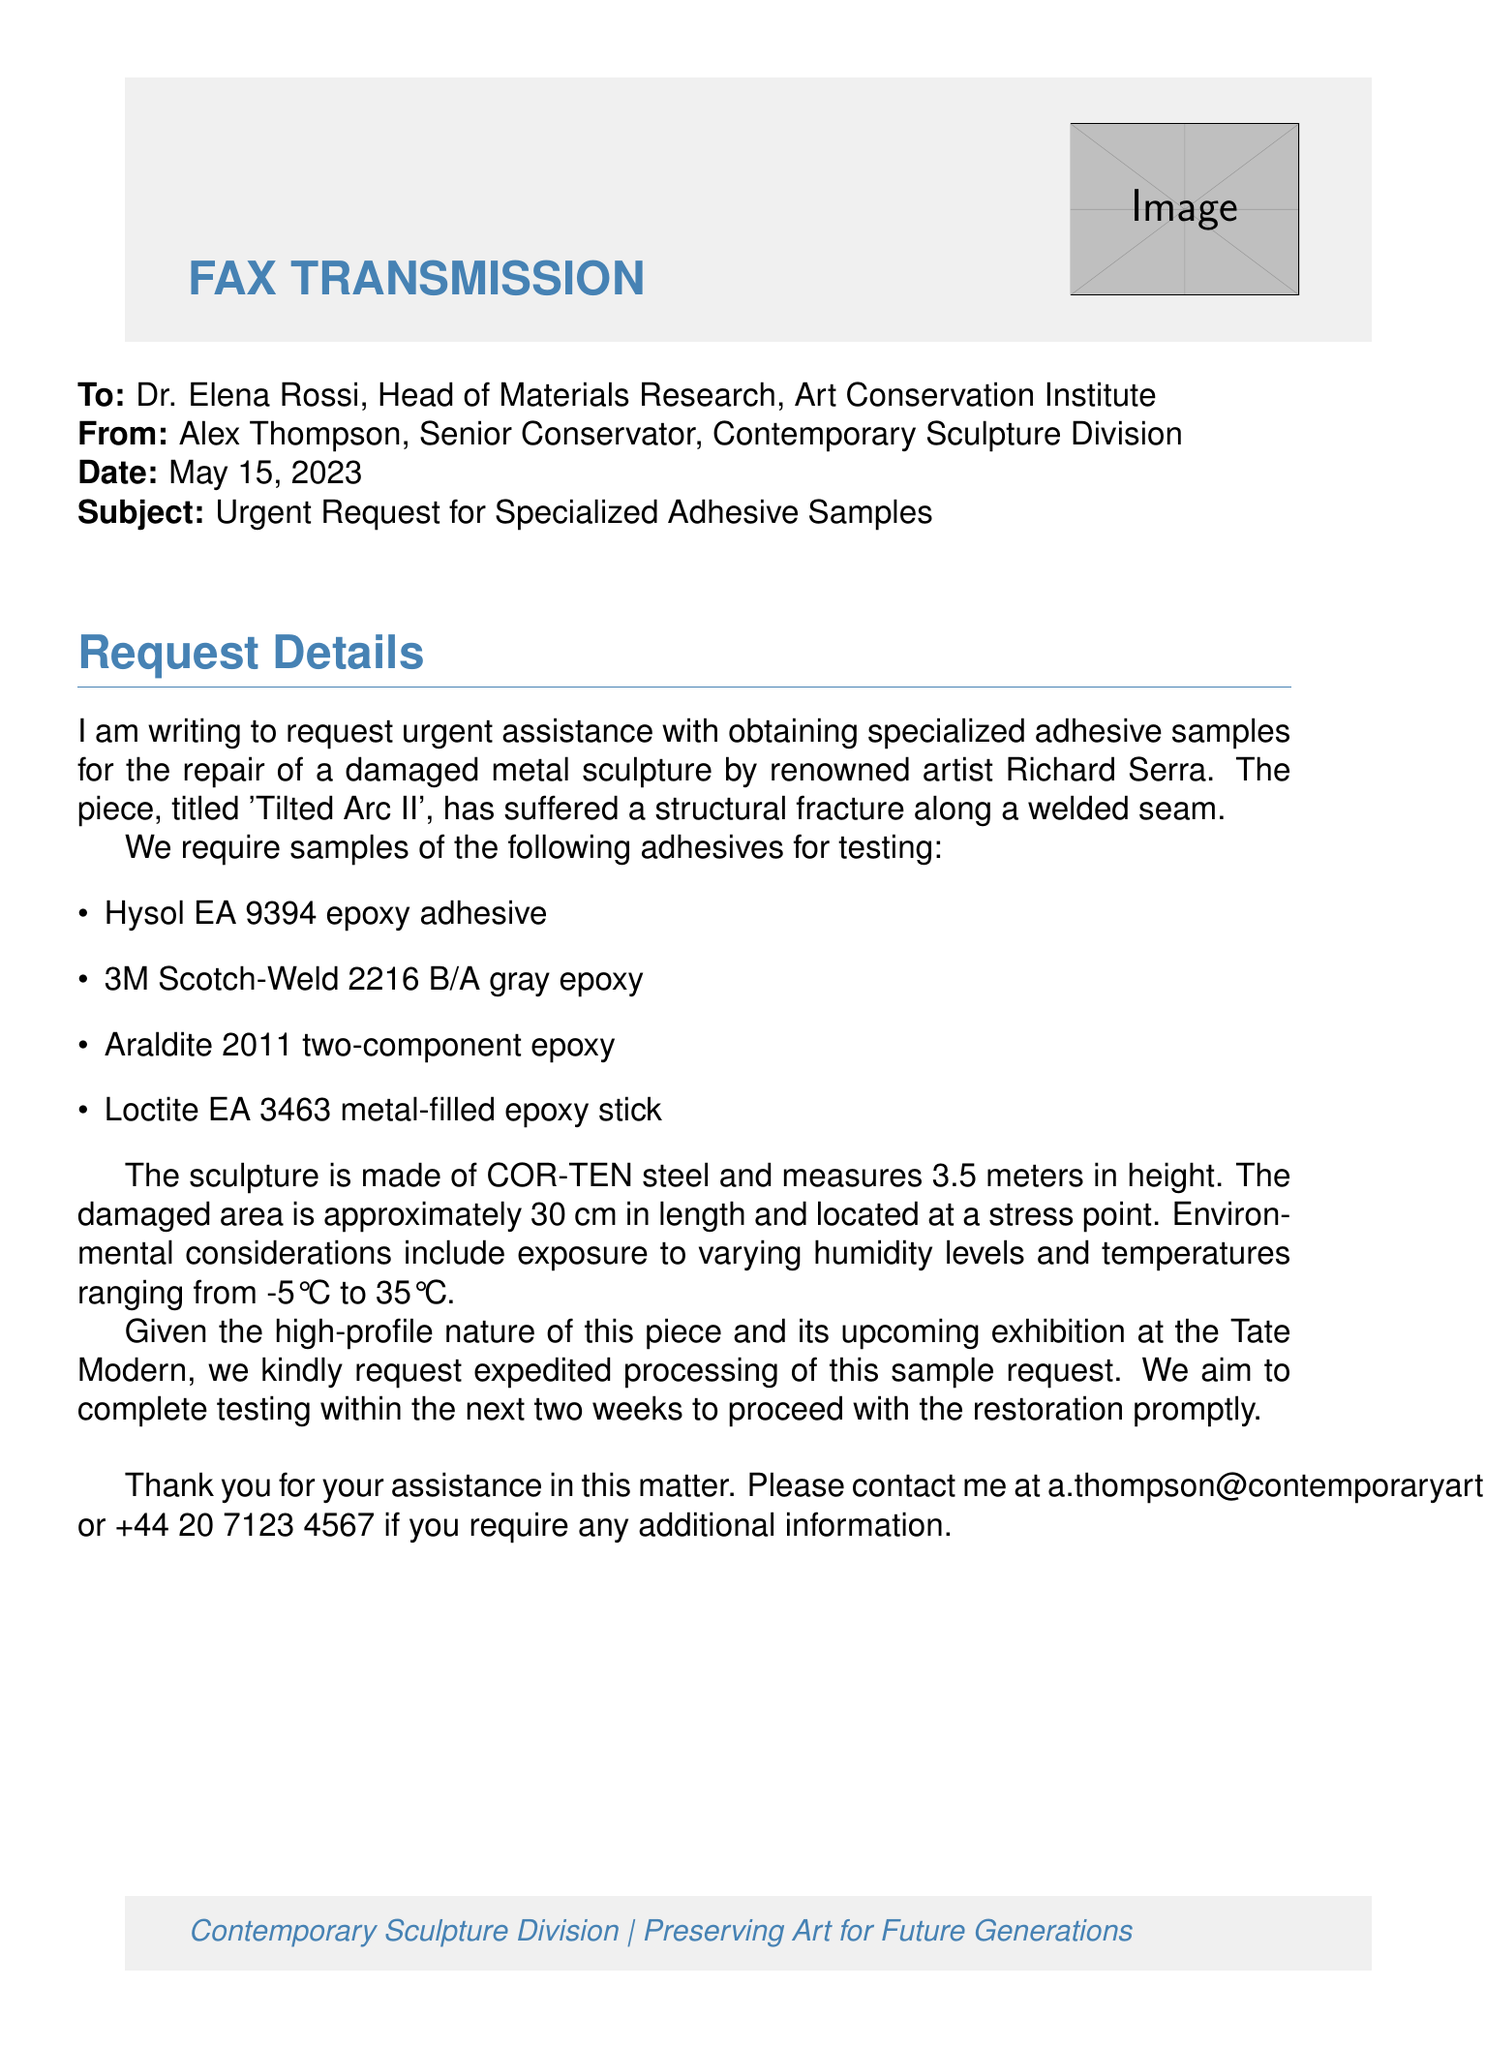what is the date of the fax? The date is explicitly stated at the top of the document.
Answer: May 15, 2023 who is the recipient of the fax? The recipient's name and title are provided in the "To" section.
Answer: Dr. Elena Rossi what is the height of the sculpture? The height of the sculpture is mentioned in the request details.
Answer: 3.5 meters how many types of adhesives are requested? The number of adhesive types is listed in the itemized section of the document.
Answer: Four what is the title of the damaged sculpture? The title of the sculpture is presented at the beginning of the request details.
Answer: Tilted Arc II what is the material of the sculpture? The material is specified in the request for adhesive samples.
Answer: COR-TEN steel what temperature range is mentioned in environmental considerations? The temperature range is detailed in the environmental considerations portion of the request.
Answer: -5°C to 35°C what is the primary purpose of the fax? The fax's intent is stated in the subject line and the request details.
Answer: Request for specialized adhesive samples how soon does the sender want to complete testing? The timeframe for completing the testing is mentioned in the request details.
Answer: Within the next two weeks 